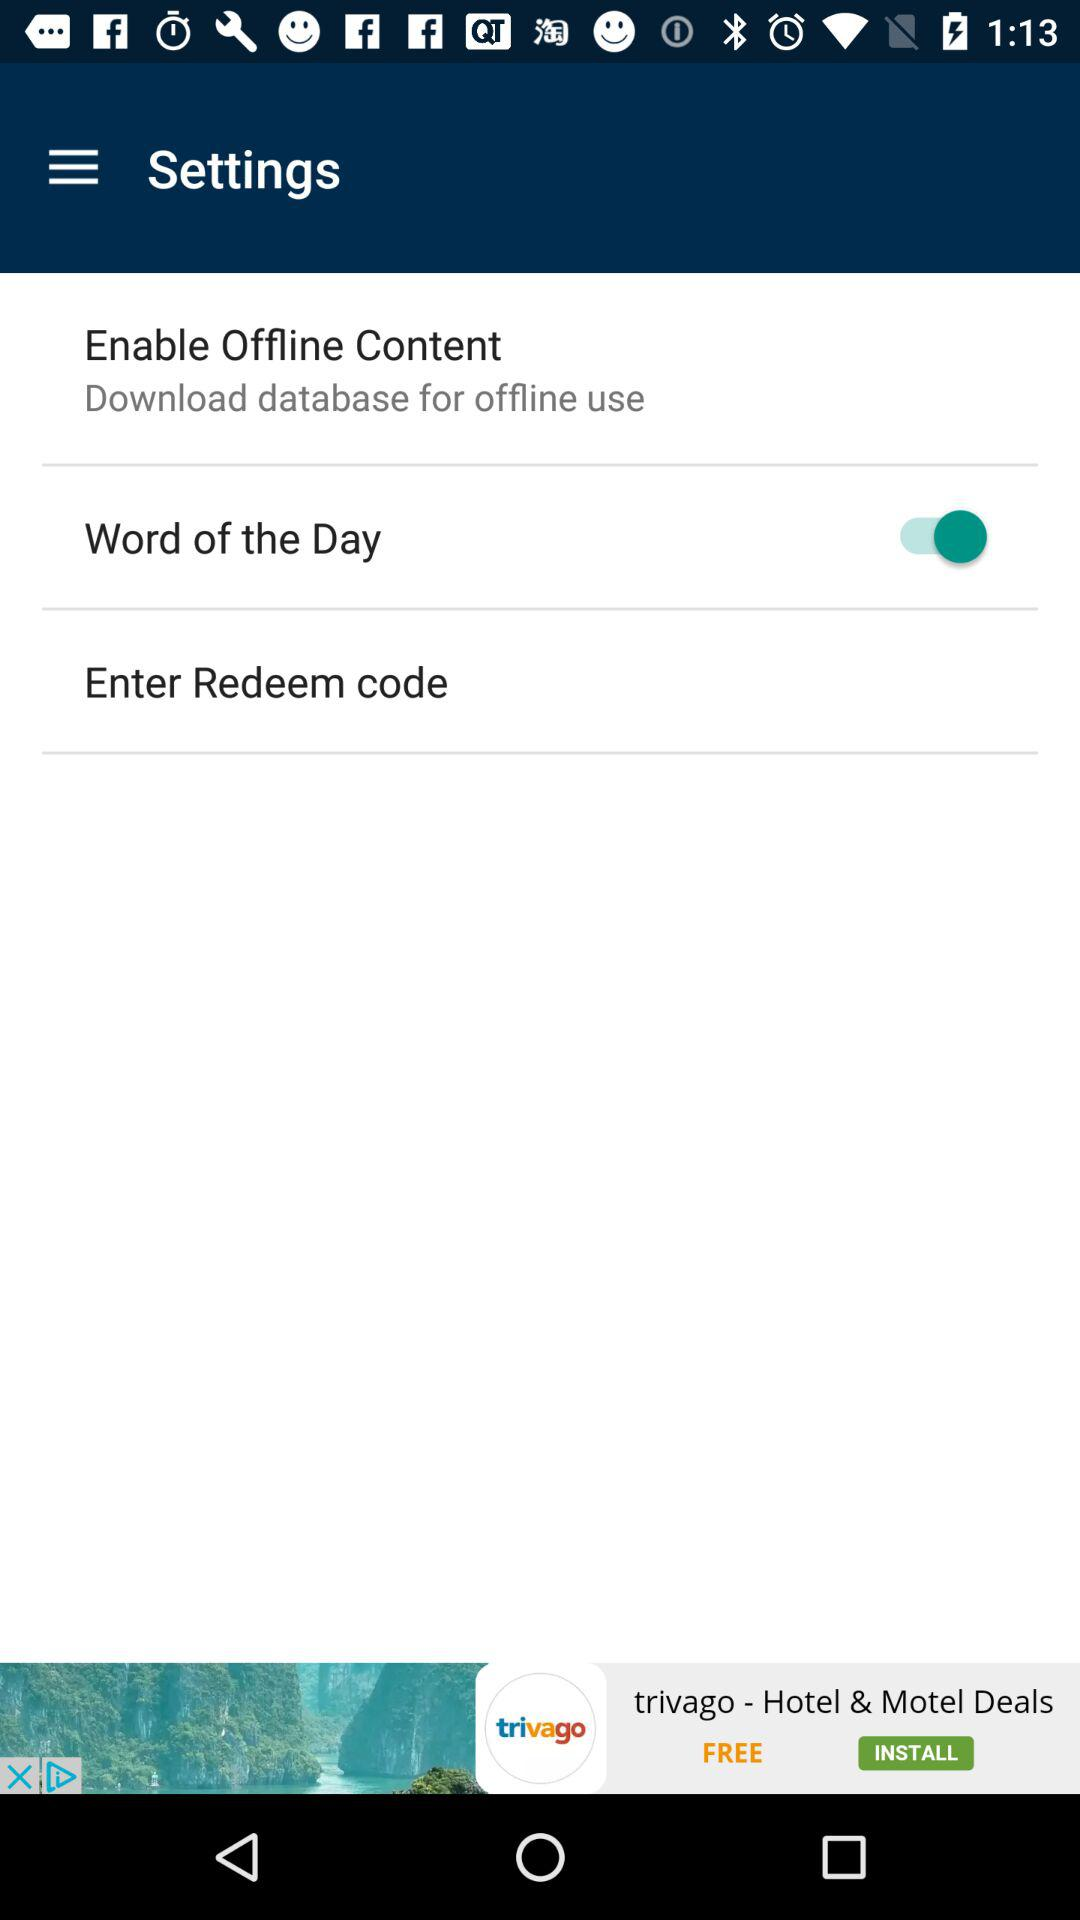What is the redeem code?
When the provided information is insufficient, respond with <no answer>. <no answer> 